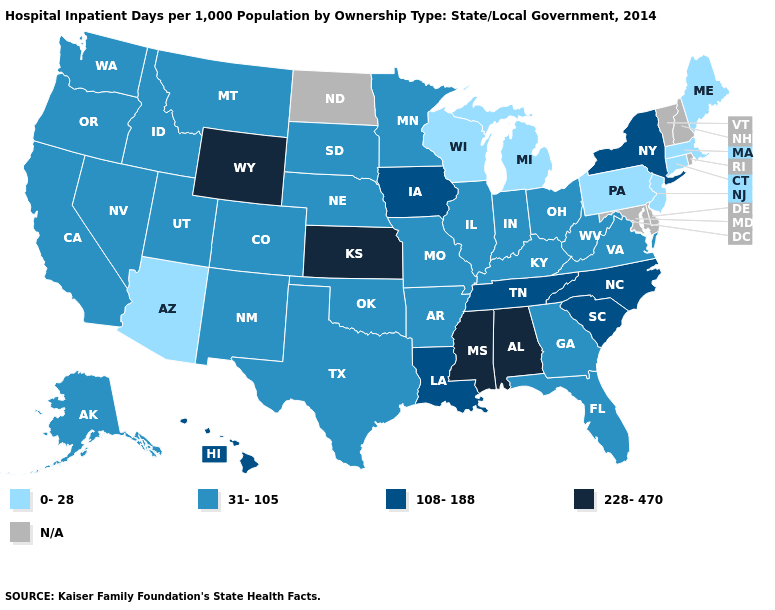Which states hav the highest value in the South?
Be succinct. Alabama, Mississippi. What is the value of Hawaii?
Be succinct. 108-188. Name the states that have a value in the range 108-188?
Keep it brief. Hawaii, Iowa, Louisiana, New York, North Carolina, South Carolina, Tennessee. Does Wyoming have the highest value in the USA?
Write a very short answer. Yes. What is the value of Mississippi?
Keep it brief. 228-470. Does Wyoming have the highest value in the West?
Give a very brief answer. Yes. Which states hav the highest value in the Northeast?
Give a very brief answer. New York. How many symbols are there in the legend?
Short answer required. 5. What is the value of Iowa?
Write a very short answer. 108-188. What is the lowest value in the Northeast?
Answer briefly. 0-28. Name the states that have a value in the range 31-105?
Keep it brief. Alaska, Arkansas, California, Colorado, Florida, Georgia, Idaho, Illinois, Indiana, Kentucky, Minnesota, Missouri, Montana, Nebraska, Nevada, New Mexico, Ohio, Oklahoma, Oregon, South Dakota, Texas, Utah, Virginia, Washington, West Virginia. What is the highest value in the MidWest ?
Answer briefly. 228-470. Does Minnesota have the lowest value in the MidWest?
Quick response, please. No. What is the highest value in the South ?
Answer briefly. 228-470. 